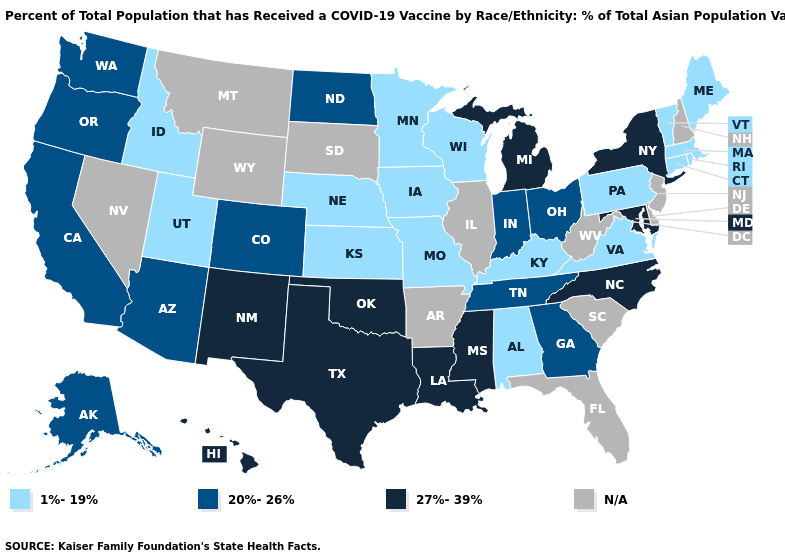How many symbols are there in the legend?
Short answer required. 4. What is the highest value in the USA?
Quick response, please. 27%-39%. Name the states that have a value in the range 1%-19%?
Keep it brief. Alabama, Connecticut, Idaho, Iowa, Kansas, Kentucky, Maine, Massachusetts, Minnesota, Missouri, Nebraska, Pennsylvania, Rhode Island, Utah, Vermont, Virginia, Wisconsin. What is the highest value in the MidWest ?
Be succinct. 27%-39%. What is the lowest value in the USA?
Answer briefly. 1%-19%. Which states have the lowest value in the West?
Short answer required. Idaho, Utah. Does the first symbol in the legend represent the smallest category?
Quick response, please. Yes. What is the highest value in the MidWest ?
Write a very short answer. 27%-39%. Which states have the highest value in the USA?
Short answer required. Hawaii, Louisiana, Maryland, Michigan, Mississippi, New Mexico, New York, North Carolina, Oklahoma, Texas. What is the highest value in the USA?
Quick response, please. 27%-39%. Which states have the highest value in the USA?
Concise answer only. Hawaii, Louisiana, Maryland, Michigan, Mississippi, New Mexico, New York, North Carolina, Oklahoma, Texas. What is the highest value in the USA?
Give a very brief answer. 27%-39%. Does North Carolina have the highest value in the South?
Quick response, please. Yes. What is the value of Mississippi?
Quick response, please. 27%-39%. 